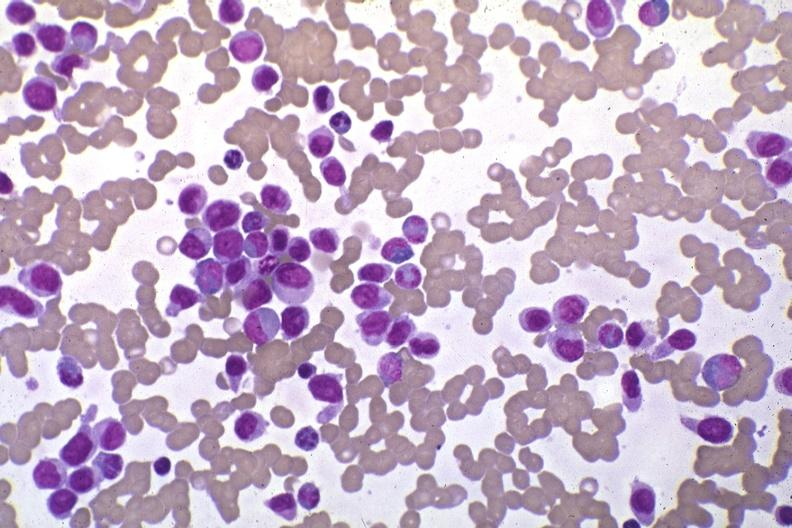what is present?
Answer the question using a single word or phrase. Blood 